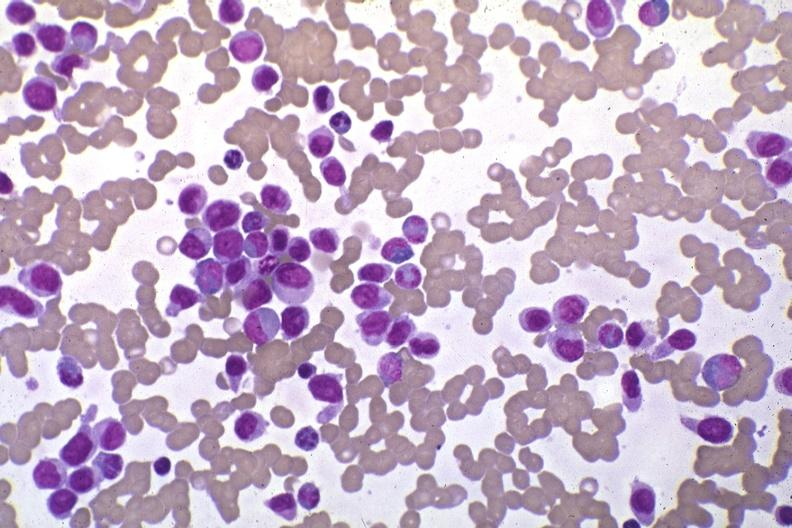what is present?
Answer the question using a single word or phrase. Blood 